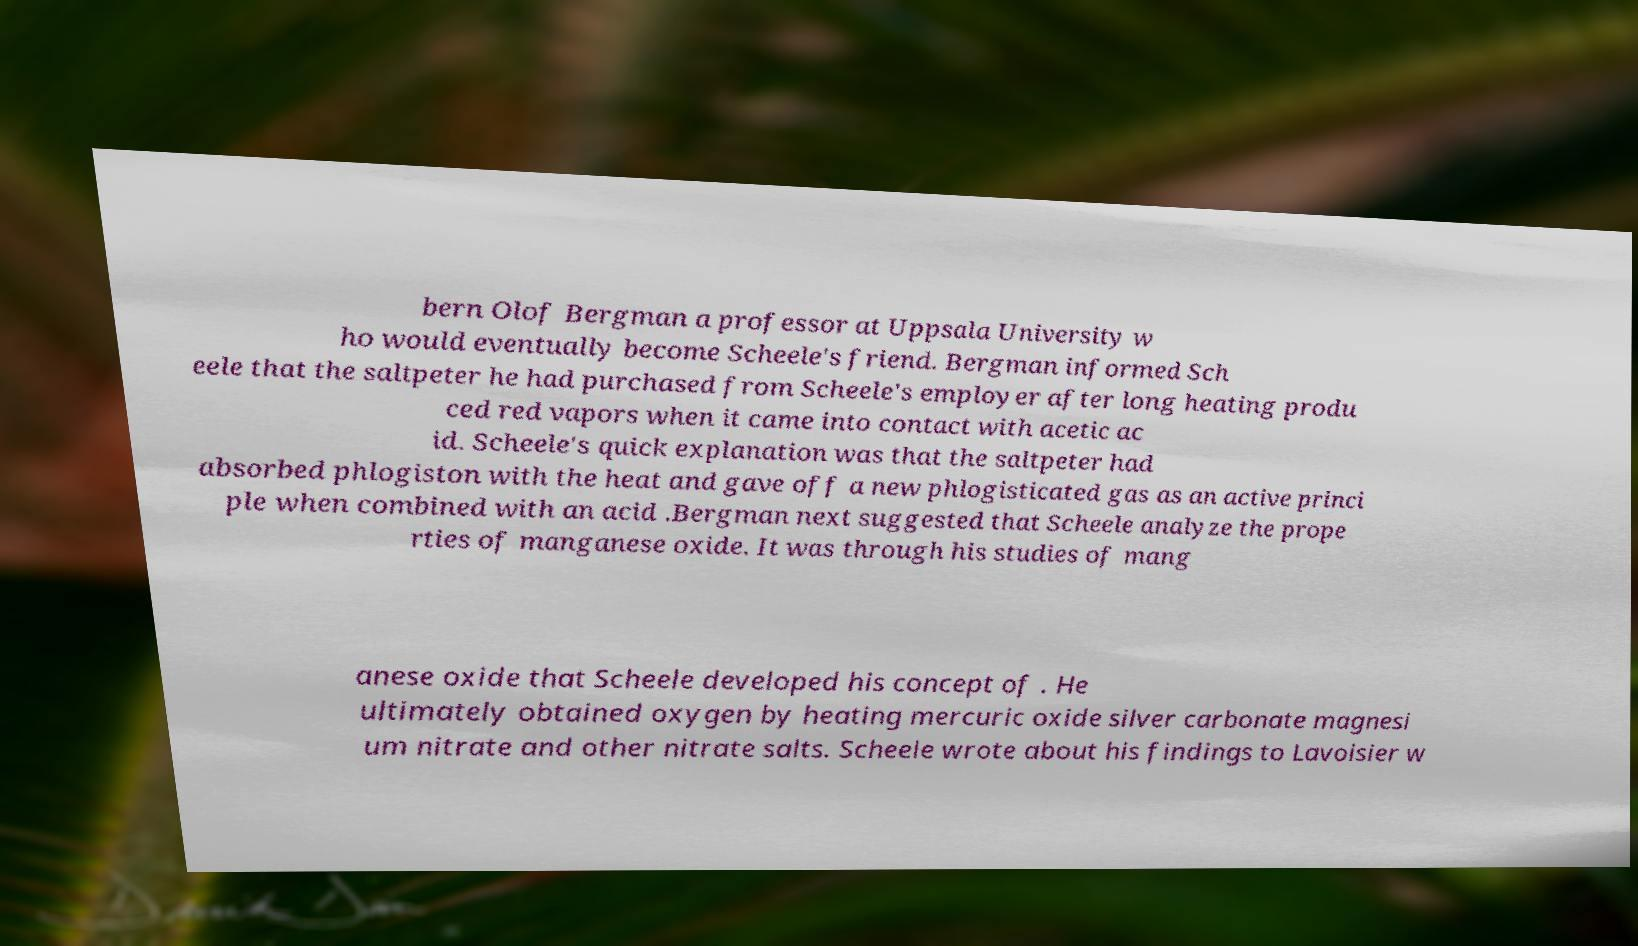There's text embedded in this image that I need extracted. Can you transcribe it verbatim? bern Olof Bergman a professor at Uppsala University w ho would eventually become Scheele's friend. Bergman informed Sch eele that the saltpeter he had purchased from Scheele's employer after long heating produ ced red vapors when it came into contact with acetic ac id. Scheele's quick explanation was that the saltpeter had absorbed phlogiston with the heat and gave off a new phlogisticated gas as an active princi ple when combined with an acid .Bergman next suggested that Scheele analyze the prope rties of manganese oxide. It was through his studies of mang anese oxide that Scheele developed his concept of . He ultimately obtained oxygen by heating mercuric oxide silver carbonate magnesi um nitrate and other nitrate salts. Scheele wrote about his findings to Lavoisier w 